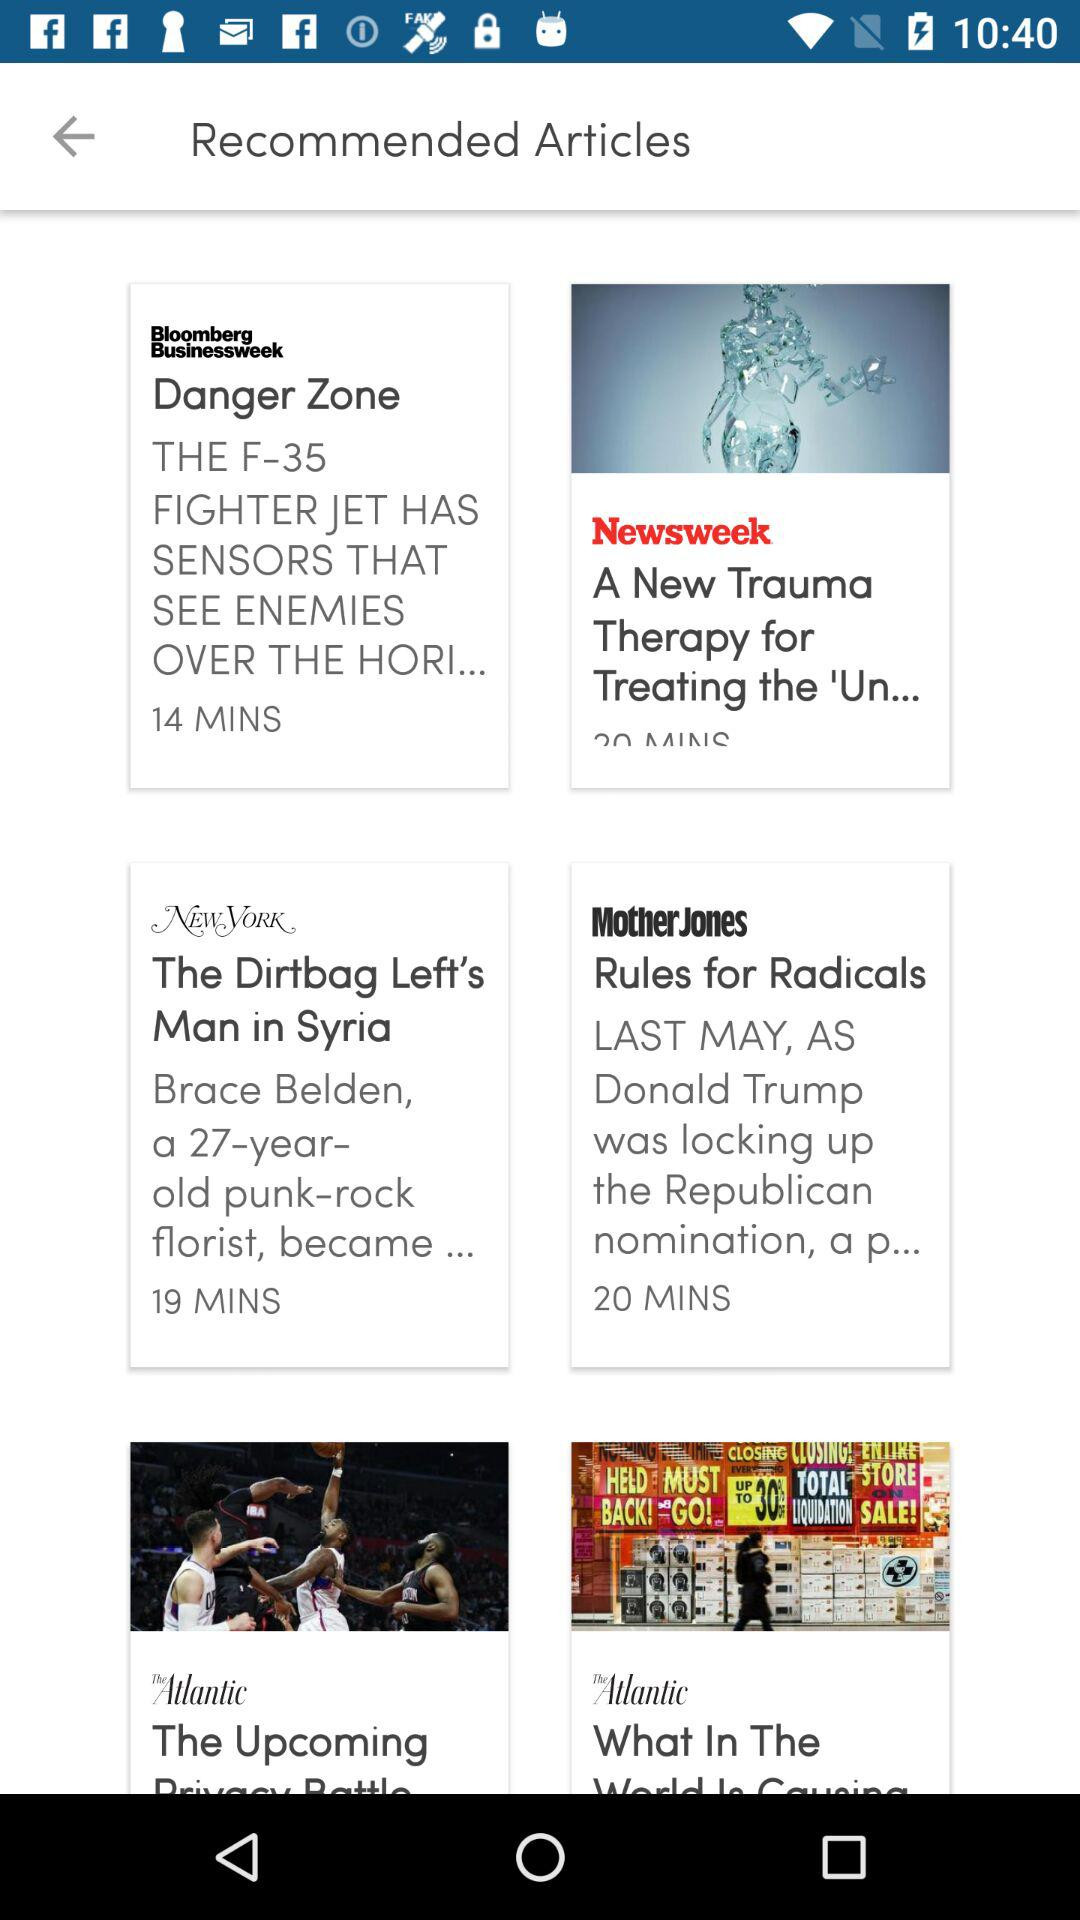Which article was published 19 minutes ago? The article "The Dirtbag Left's Man in Syria" was published 19 minutes ago. 